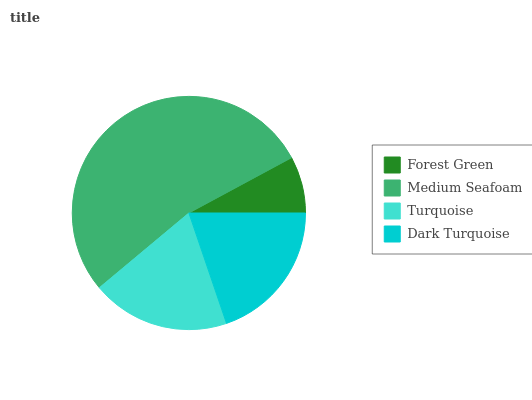Is Forest Green the minimum?
Answer yes or no. Yes. Is Medium Seafoam the maximum?
Answer yes or no. Yes. Is Turquoise the minimum?
Answer yes or no. No. Is Turquoise the maximum?
Answer yes or no. No. Is Medium Seafoam greater than Turquoise?
Answer yes or no. Yes. Is Turquoise less than Medium Seafoam?
Answer yes or no. Yes. Is Turquoise greater than Medium Seafoam?
Answer yes or no. No. Is Medium Seafoam less than Turquoise?
Answer yes or no. No. Is Dark Turquoise the high median?
Answer yes or no. Yes. Is Turquoise the low median?
Answer yes or no. Yes. Is Forest Green the high median?
Answer yes or no. No. Is Forest Green the low median?
Answer yes or no. No. 